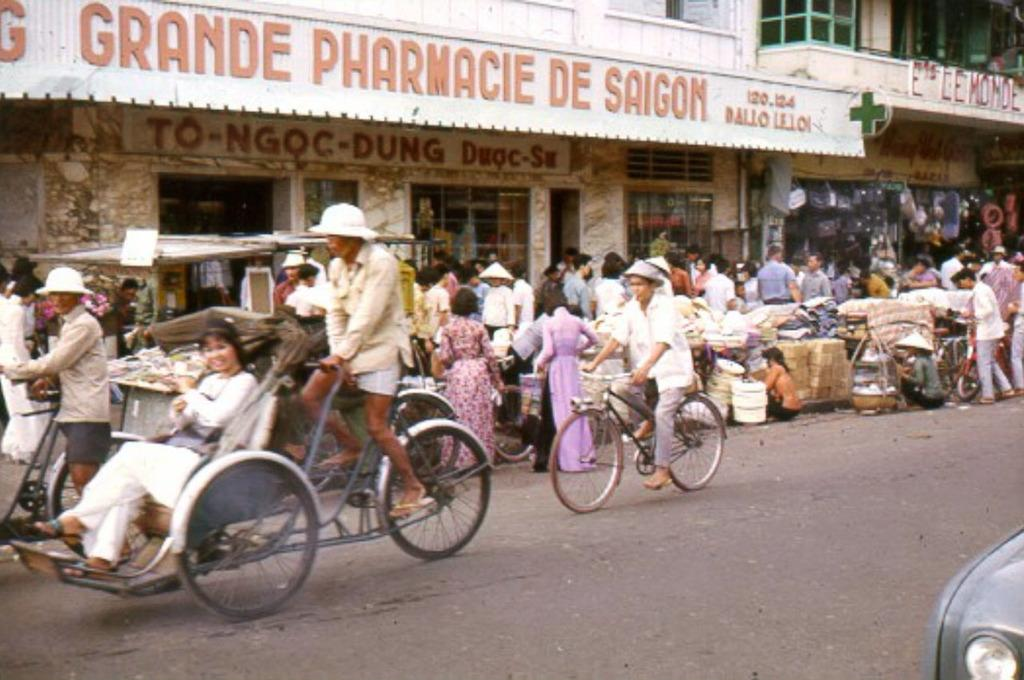What are the two persons in the image doing? The two persons are on bicycles in the image. What else can be seen on the road in the image? There are people standing on the road in the image. What object is present in the image that is not a person or a bicycle? There is a board in the image. What type of structure is visible in the image? There is a building in the image. What type of fan is visible in the image? There is no fan present in the image. Is there an alley visible in the image? The image does not show an alley; it features a road with people and bicycles. 